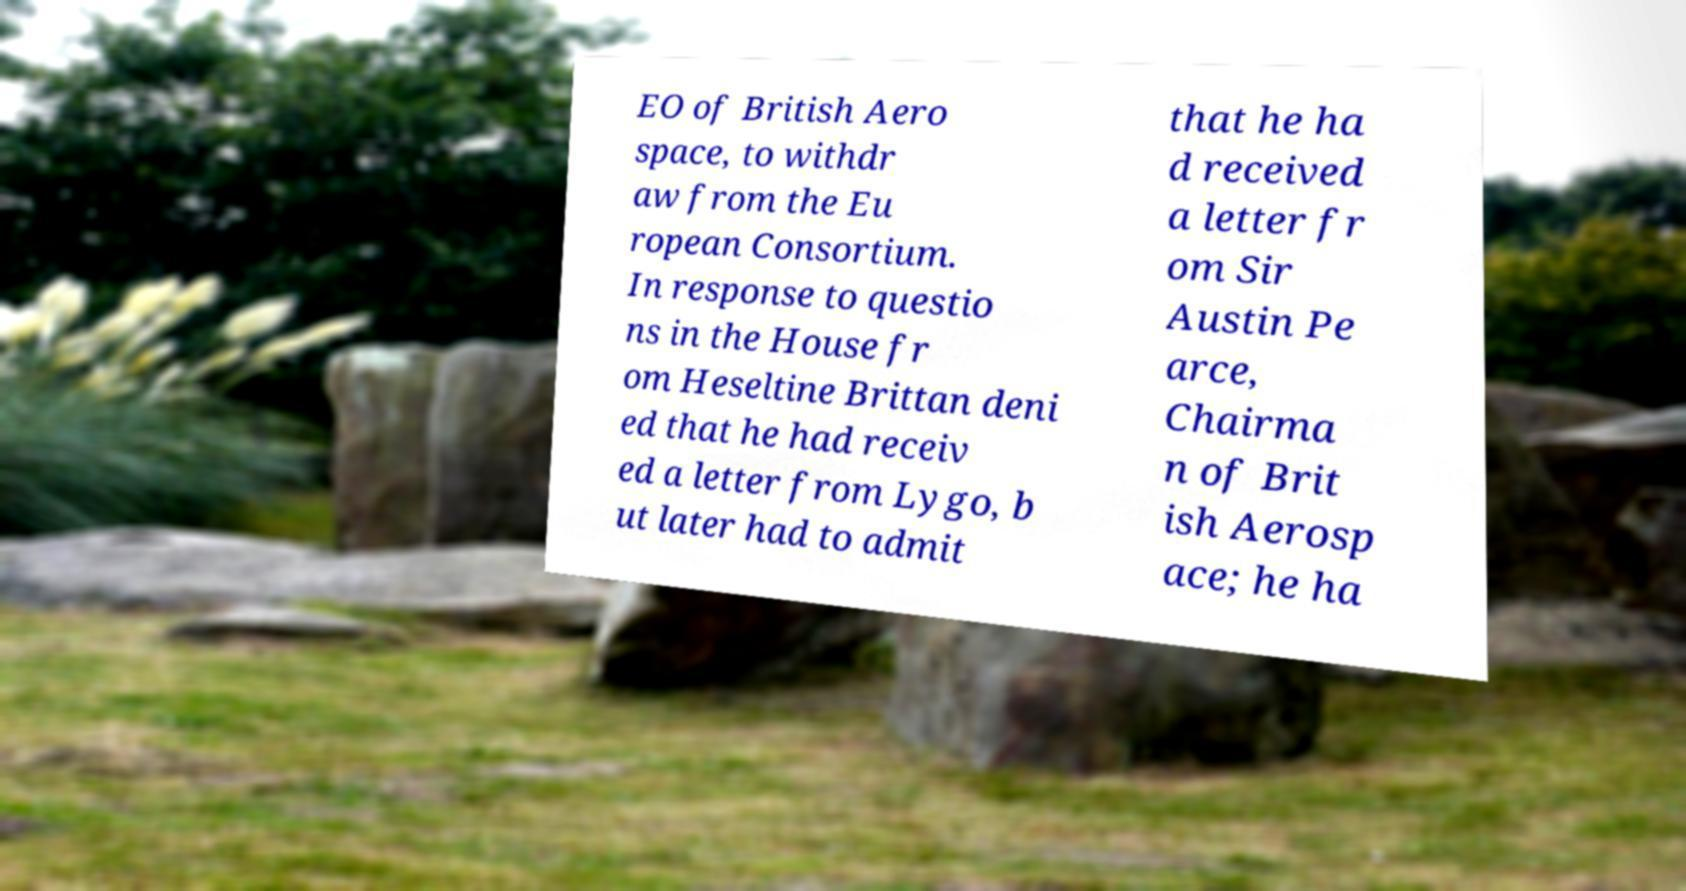Can you read and provide the text displayed in the image?This photo seems to have some interesting text. Can you extract and type it out for me? EO of British Aero space, to withdr aw from the Eu ropean Consortium. In response to questio ns in the House fr om Heseltine Brittan deni ed that he had receiv ed a letter from Lygo, b ut later had to admit that he ha d received a letter fr om Sir Austin Pe arce, Chairma n of Brit ish Aerosp ace; he ha 